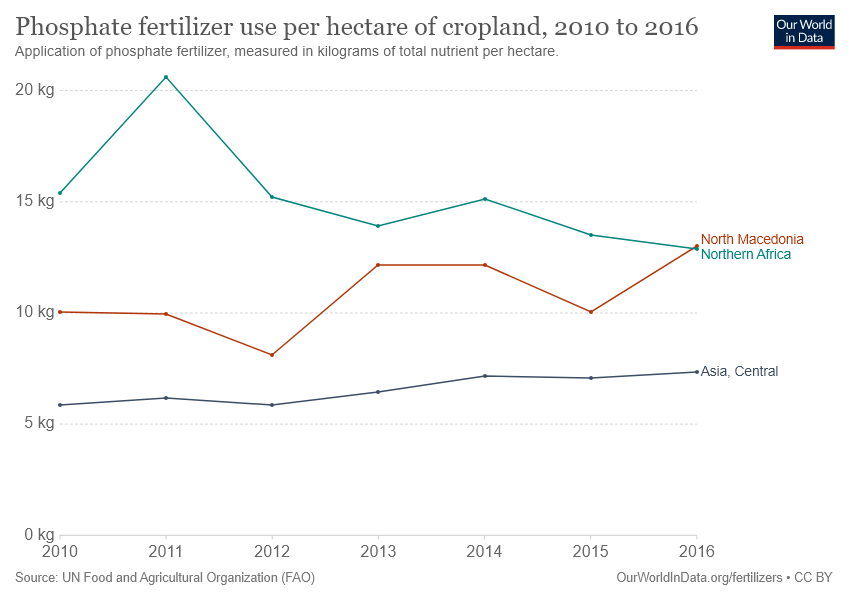Point out several critical features in this image. In 2011, the use of phosphate fertilizer per hectare of cropland was at its highest level. In five years, the value of the red dotted line will be greater than 10kg. 